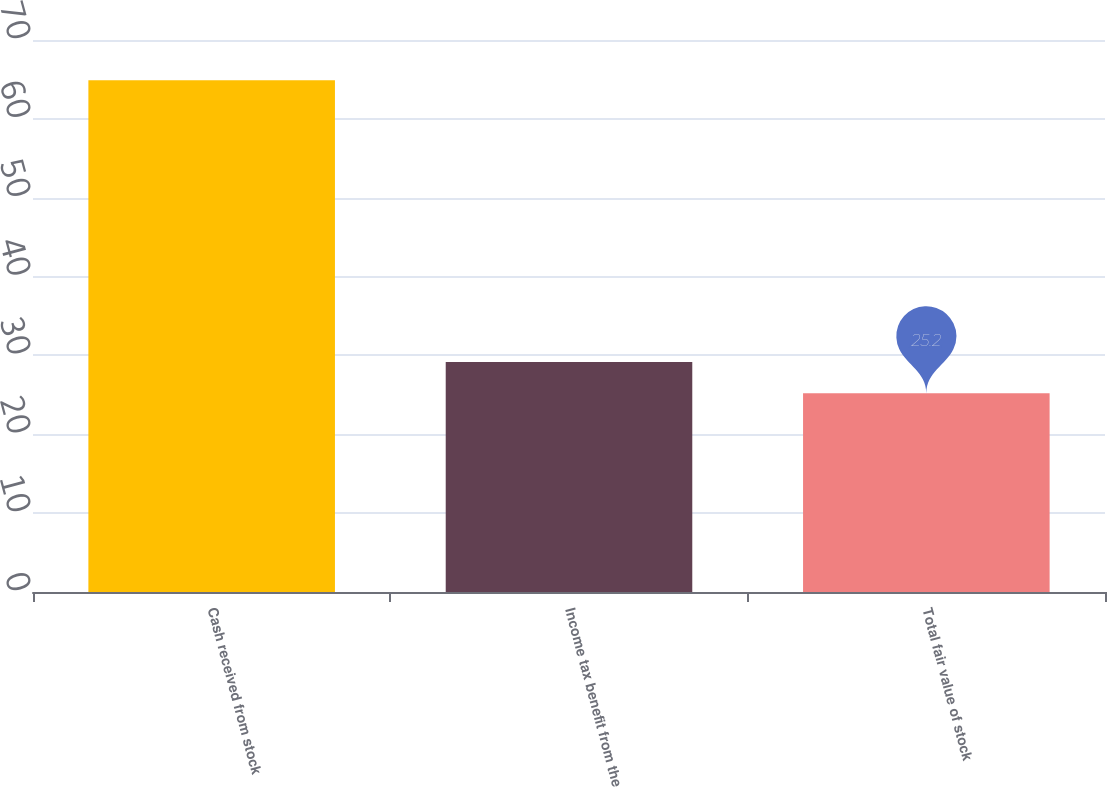Convert chart to OTSL. <chart><loc_0><loc_0><loc_500><loc_500><bar_chart><fcel>Cash received from stock<fcel>Income tax benefit from the<fcel>Total fair value of stock<nl><fcel>64.9<fcel>29.17<fcel>25.2<nl></chart> 